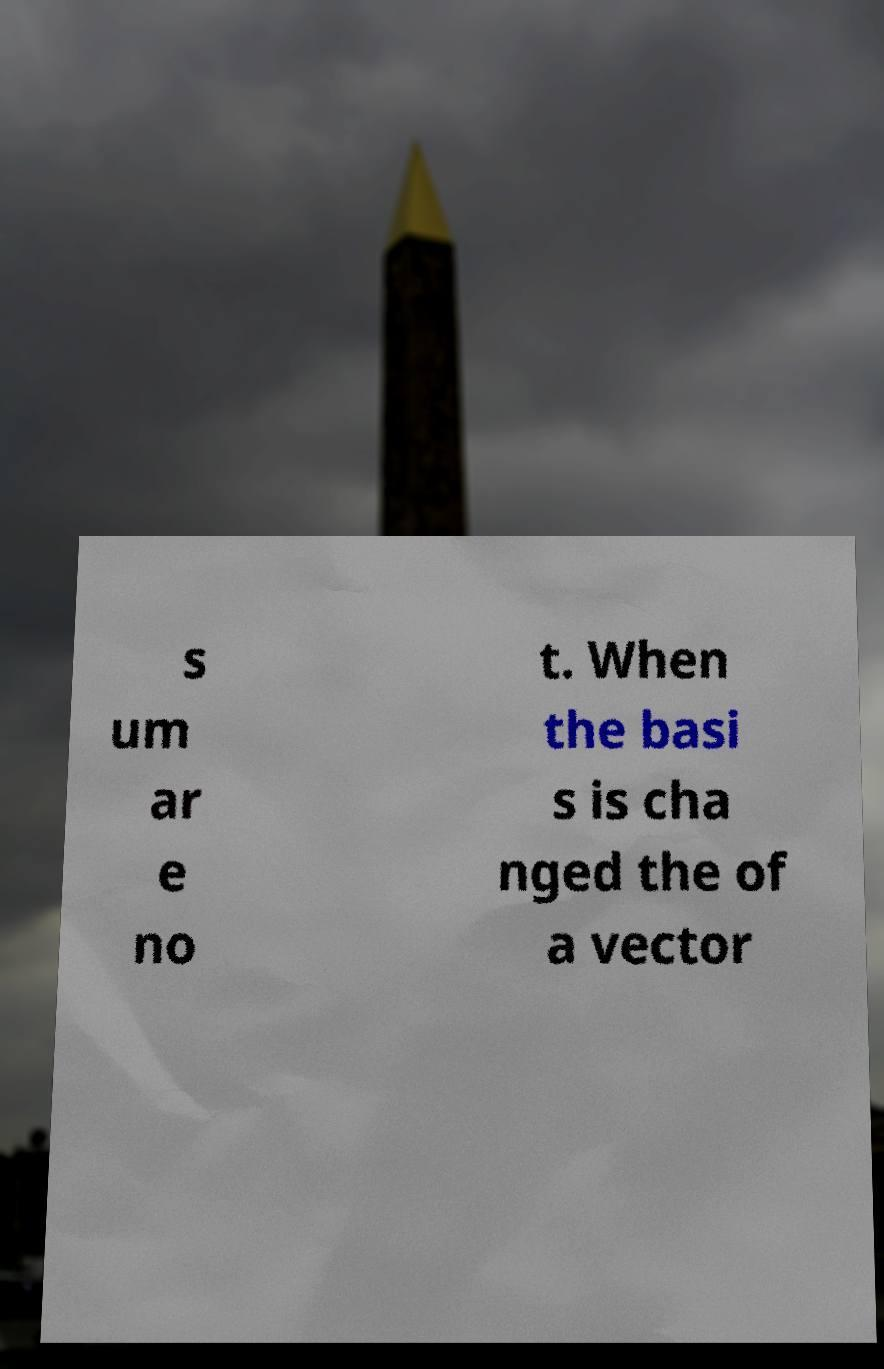What messages or text are displayed in this image? I need them in a readable, typed format. s um ar e no t. When the basi s is cha nged the of a vector 